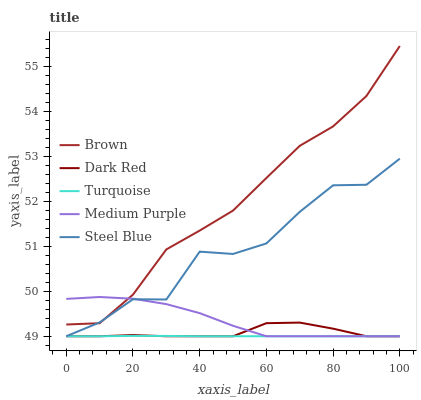Does Turquoise have the minimum area under the curve?
Answer yes or no. Yes. Does Brown have the maximum area under the curve?
Answer yes or no. Yes. Does Brown have the minimum area under the curve?
Answer yes or no. No. Does Turquoise have the maximum area under the curve?
Answer yes or no. No. Is Turquoise the smoothest?
Answer yes or no. Yes. Is Steel Blue the roughest?
Answer yes or no. Yes. Is Brown the smoothest?
Answer yes or no. No. Is Brown the roughest?
Answer yes or no. No. Does Medium Purple have the lowest value?
Answer yes or no. Yes. Does Brown have the lowest value?
Answer yes or no. No. Does Brown have the highest value?
Answer yes or no. Yes. Does Turquoise have the highest value?
Answer yes or no. No. Is Dark Red less than Brown?
Answer yes or no. Yes. Is Brown greater than Dark Red?
Answer yes or no. Yes. Does Turquoise intersect Steel Blue?
Answer yes or no. Yes. Is Turquoise less than Steel Blue?
Answer yes or no. No. Is Turquoise greater than Steel Blue?
Answer yes or no. No. Does Dark Red intersect Brown?
Answer yes or no. No. 